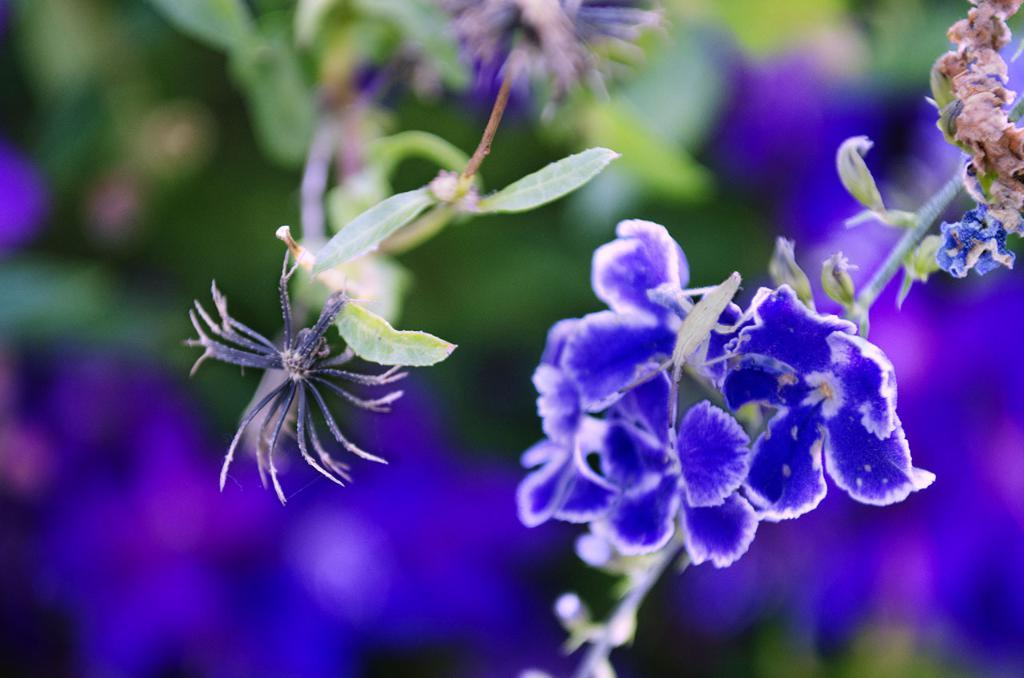What type of plants can be seen in the image? There are flowers and leaves in the image. Can you describe the background of the image? The background of the image is blurry. What type of game is the governor playing in the image? There is no game or governor present in the image; it features flowers and leaves with a blurry background. Can you tell me how many bees are visible in the image? There are no bees present in the image; it features flowers and leaves with a blurry background. 